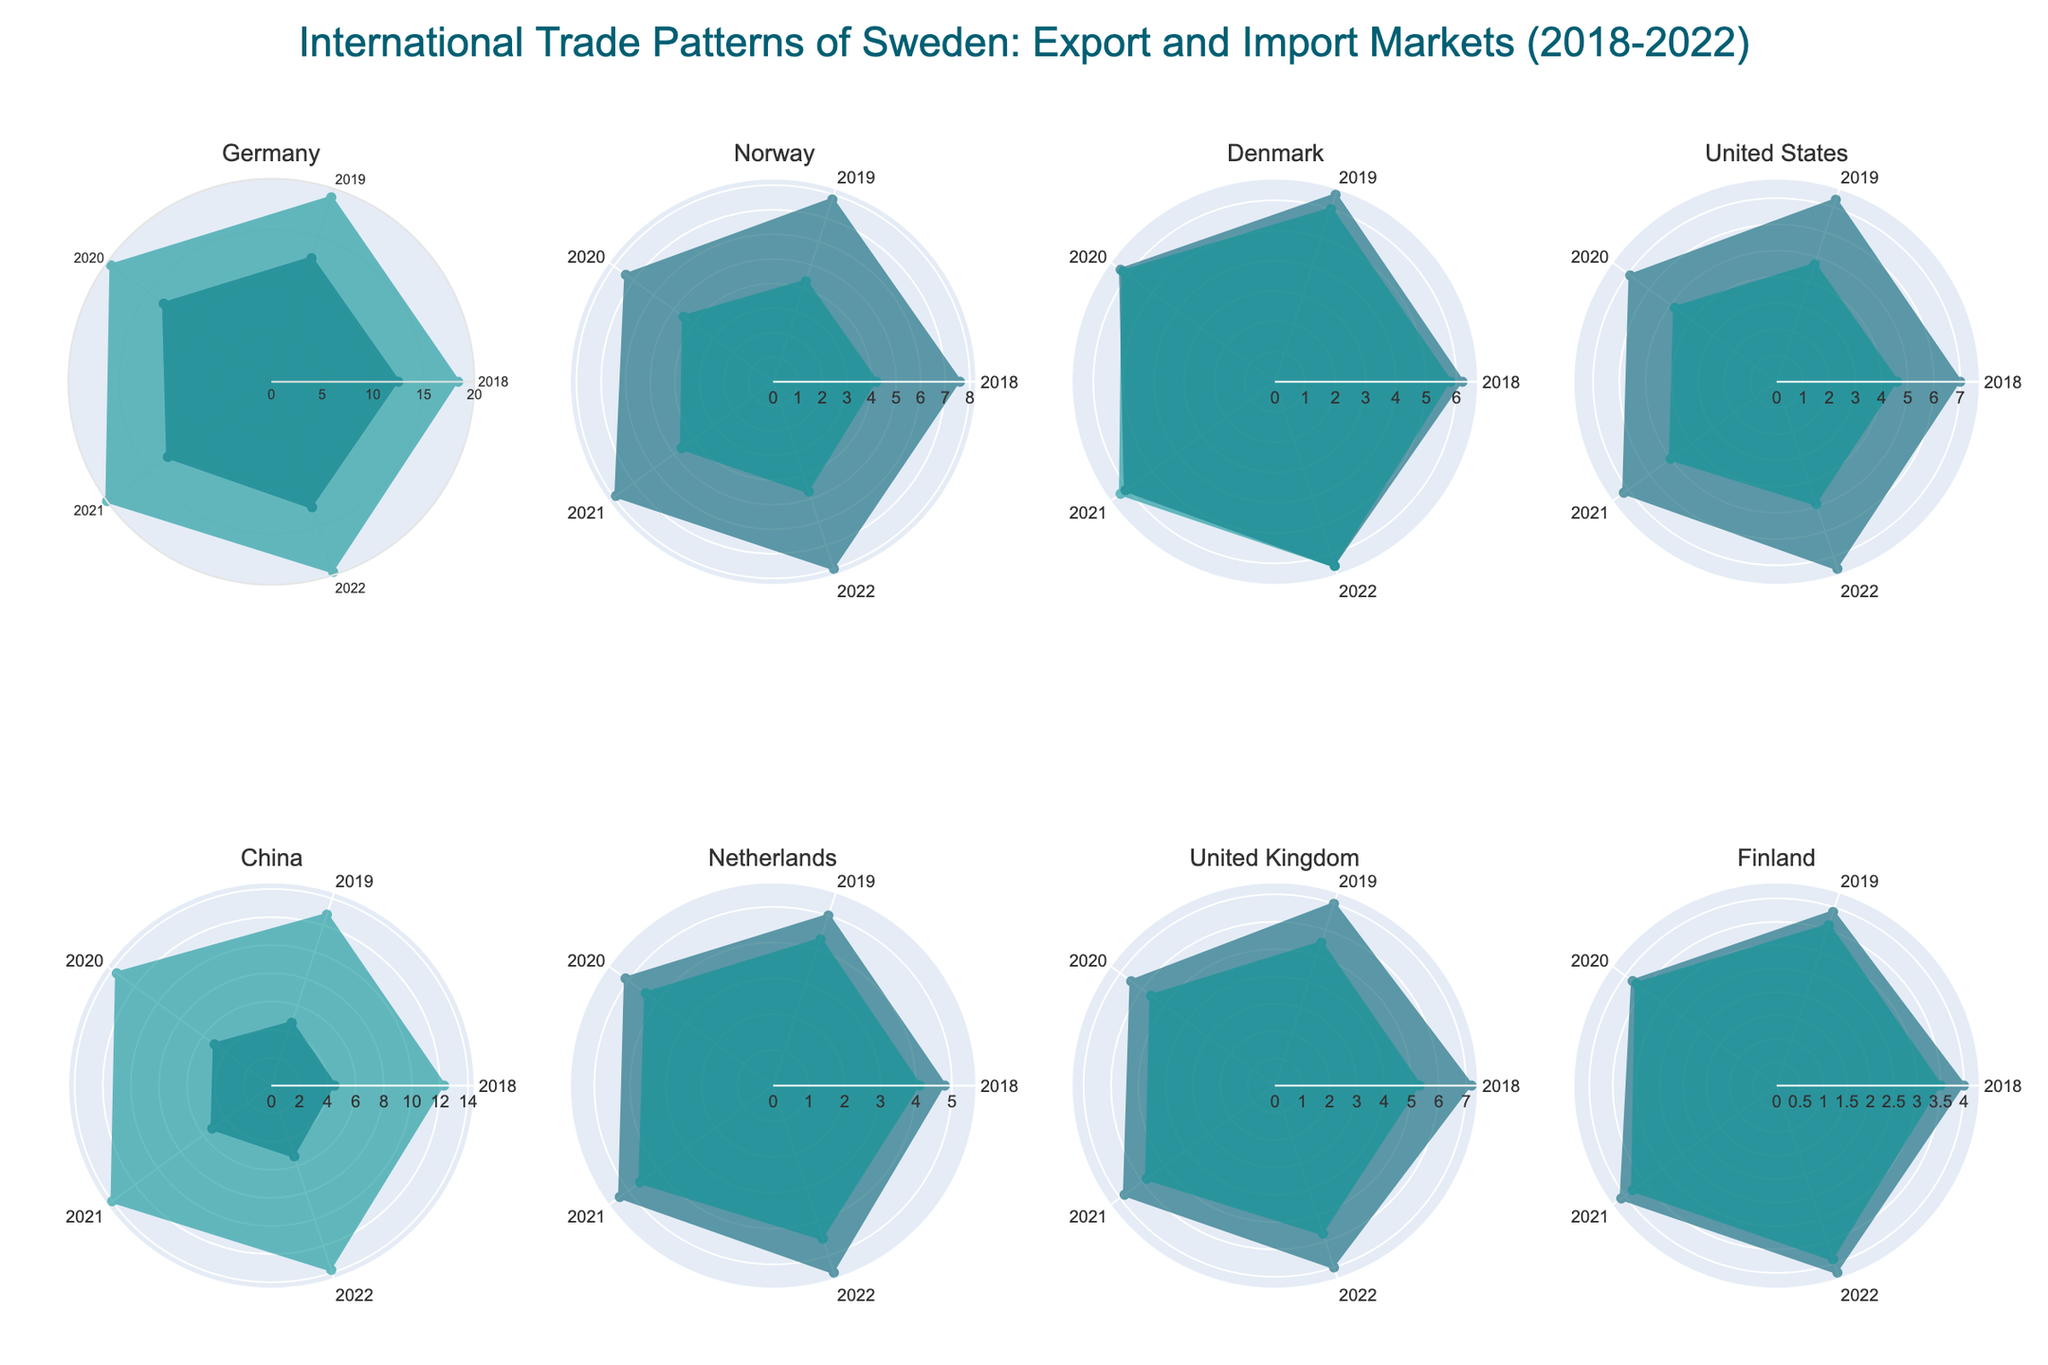What's the title of the figure? The title is written at the top of the figure in a larger font and distinct color. It is designed to give a quick overview of the plot's content.
Answer: International Trade Patterns of Sweden: Export and Import Markets (2018-2022) How many countries are included in the subplots? By counting the subplot titles, we identify the individual countries analyzed in the figure. Each subplot is titled with a country's name, totaling eight.
Answer: Eight What's the trend of Sweden's exports to Germany from 2018 to 2022? By examining the radar chart segment for Germany under "Export," we observe a relatively stable pattern with minor fluctuations between 12.5 and 13.1.
Answer: Stable with minor fluctuations Which country has the highest import value in the year 2020? By examining the radial extent of the "Import" lines in 2020 for each country, we identify the longest radius. China's import line reaches the highest value at 13.6.
Answer: China Compare the export values for Norway and Denmark in 2022. Which one is higher? Look at the 2022 points on the radar charts for both Norway and Denmark under "Export." Norway's is at 8.0 and Denmark's is at 6.4, making Norway higher.
Answer: Norway What's the average import value of Sweden from the United States over the five years? Sum the import values from the United States (4.6, 4.7, 4.8, 5.0, 4.9) and divide by 5. Calculation steps: (4.6 + 4.7 + 4.8 + 5.0 + 4.9) = 24.0 / 5 = 4.8.
Answer: 4.8 Which country shows the most significant increase in export value from 2018 to 2022? By comparing the start and end points on the "Export" sections across all countries, note that China increases from 4.5 to 5.3, marking a significant relative growth.
Answer: China What color represents the import data in the figure? By systematically observing the color scheme applied to the "Import" category across multiple subplots, identify a consistent color. Blue is used for imports.
Answer: Blue Is there a country where the import value consistently increased every year from 2018 to 2022? Examine the import values year on year for each country, noting trends without drops. China’s import values rise consistently from 12.3 to 13.8.
Answer: China Which country had nearly equal export and import values in 2021? Compare each country's export and import values for 2021 and identify those with minimal difference. The Netherlands had export at 5.3 and import at 4.6, differing slightly but considered nearly equal.
Answer: Netherlands 